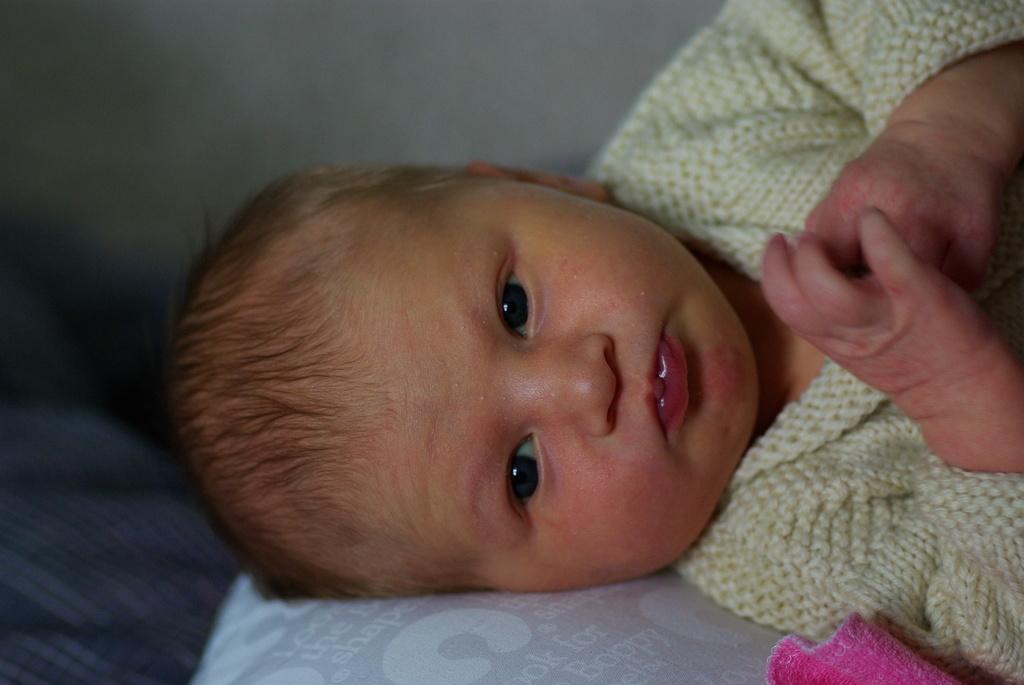In one or two sentences, can you explain what this image depicts? This picture is mainly highlighted with a baby wearing a sweater and at the bottom portion of the picture it seems like a pillow and we can see a pink cloth. 